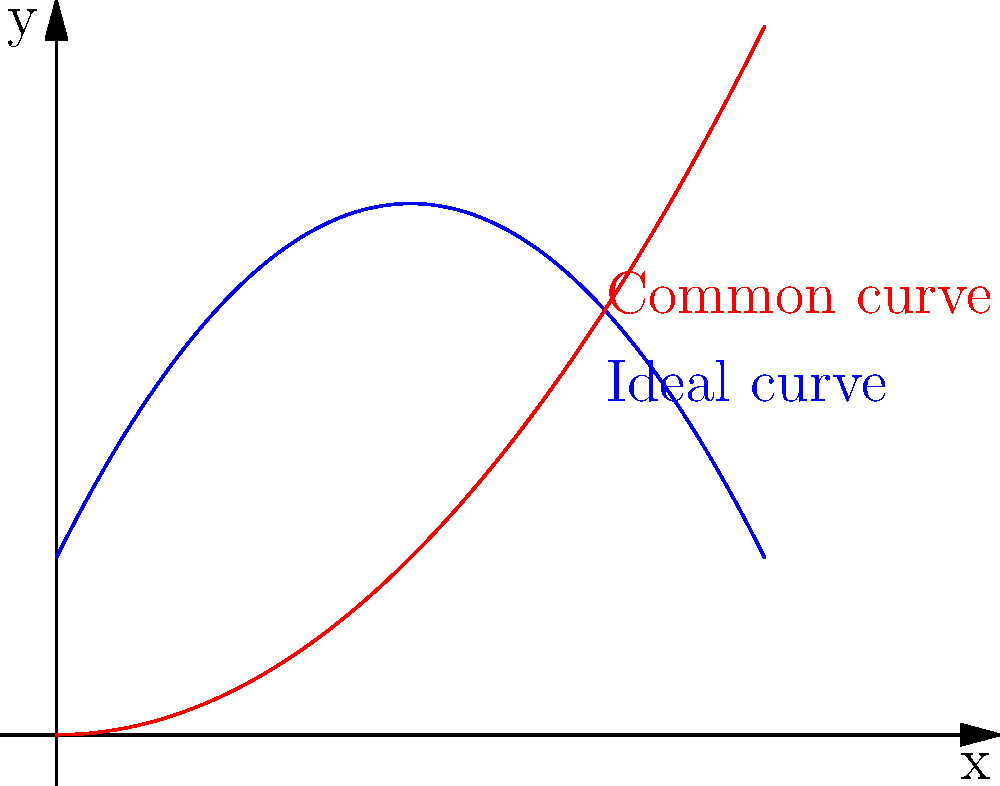As a rollerblader designing a half-pipe, you want to maximize air time and trick potential. Given the graph showing two curve profiles for a half-pipe, which curve (blue or red) would be more suitable for achieving higher jumps and longer air time? Explain why based on the shape of the curves. To determine which curve is more suitable for achieving higher jumps and longer air time, we need to analyze the shapes of both curves:

1. Blue curve:
   - Has a more gradual slope at the bottom
   - Steepens as it approaches the top
   - Resembles a parabola with a vertical stretch

2. Red curve:
   - Has a steeper slope at the bottom
   - Flattens out more at the top
   - Resembles a standard parabola

The blue curve is more suitable for achieving higher jumps and longer air time because:

a) Gradual slope at the bottom:
   - Allows for a smoother entry and exit
   - Reduces the abrupt change in direction, preserving more energy

b) Steepening towards the top:
   - Provides a "kicker" effect at the top
   - Helps redirect the skater's momentum upwards

c) Overall shape:
   - Allows for better speed maintenance throughout the curve
   - Provides a more natural transition from horizontal to vertical motion

The combination of these factors results in:
1. Higher vertical velocity at the top of the ramp
2. More efficient energy transfer from horizontal to vertical motion
3. Reduced energy loss due to impact and direction changes

In contrast, the red curve's steeper bottom and flatter top would result in:
1. More abrupt direction changes, leading to energy loss
2. Less upward momentum at the top of the ramp
3. Shorter air time and lower jump height

Therefore, the blue curve is more suitable for maximizing air time and trick potential in a half-pipe design.
Answer: Blue curve 